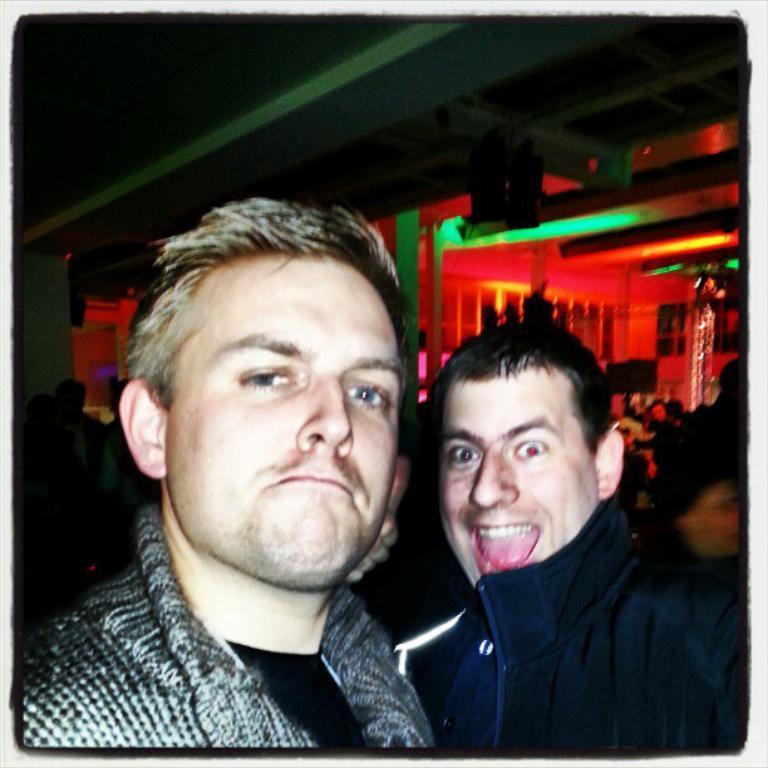Please provide a concise description of this image. In the center of the image there are two persons. In the background there is a ceiling, lights and wall. 